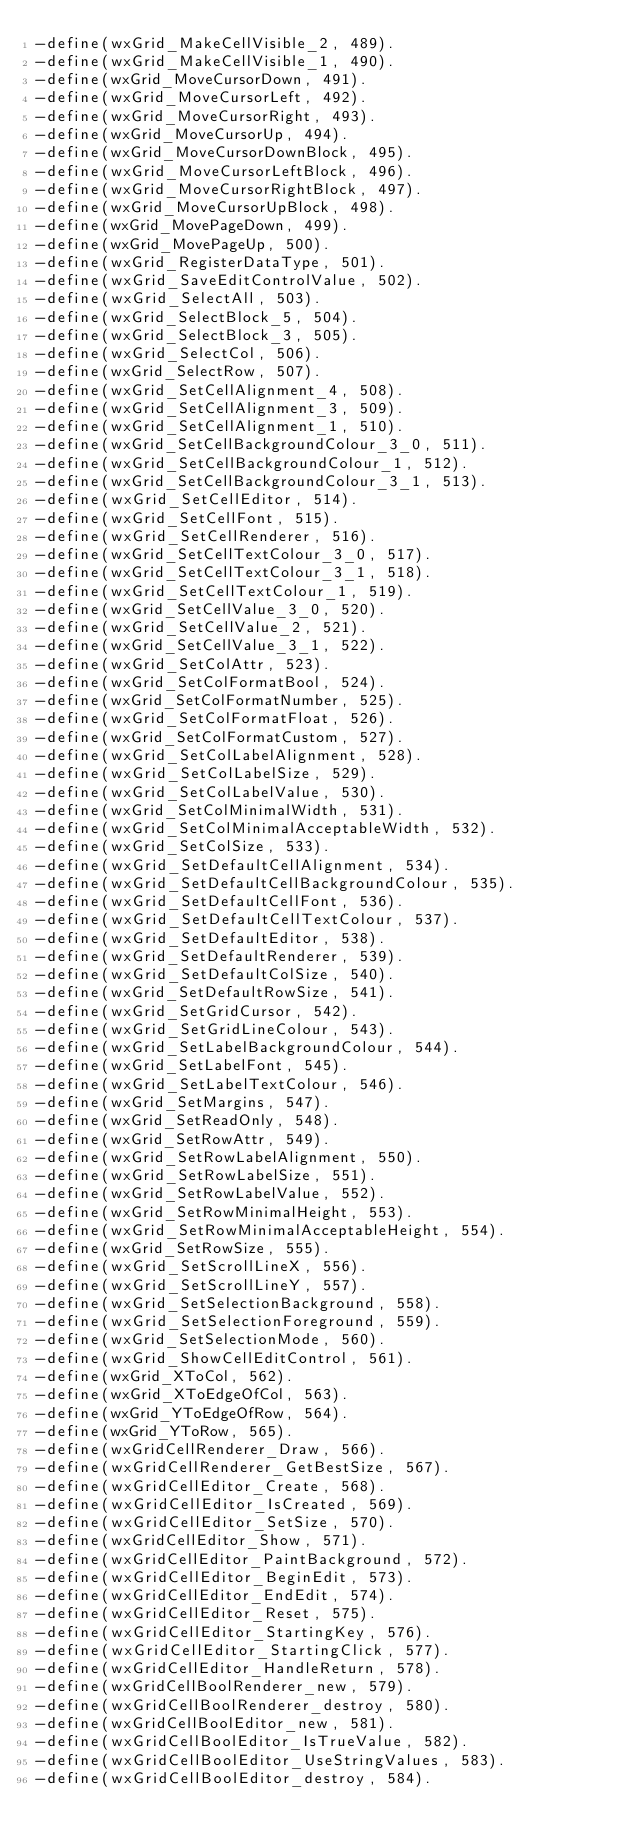<code> <loc_0><loc_0><loc_500><loc_500><_Erlang_>-define(wxGrid_MakeCellVisible_2, 489).
-define(wxGrid_MakeCellVisible_1, 490).
-define(wxGrid_MoveCursorDown, 491).
-define(wxGrid_MoveCursorLeft, 492).
-define(wxGrid_MoveCursorRight, 493).
-define(wxGrid_MoveCursorUp, 494).
-define(wxGrid_MoveCursorDownBlock, 495).
-define(wxGrid_MoveCursorLeftBlock, 496).
-define(wxGrid_MoveCursorRightBlock, 497).
-define(wxGrid_MoveCursorUpBlock, 498).
-define(wxGrid_MovePageDown, 499).
-define(wxGrid_MovePageUp, 500).
-define(wxGrid_RegisterDataType, 501).
-define(wxGrid_SaveEditControlValue, 502).
-define(wxGrid_SelectAll, 503).
-define(wxGrid_SelectBlock_5, 504).
-define(wxGrid_SelectBlock_3, 505).
-define(wxGrid_SelectCol, 506).
-define(wxGrid_SelectRow, 507).
-define(wxGrid_SetCellAlignment_4, 508).
-define(wxGrid_SetCellAlignment_3, 509).
-define(wxGrid_SetCellAlignment_1, 510).
-define(wxGrid_SetCellBackgroundColour_3_0, 511).
-define(wxGrid_SetCellBackgroundColour_1, 512).
-define(wxGrid_SetCellBackgroundColour_3_1, 513).
-define(wxGrid_SetCellEditor, 514).
-define(wxGrid_SetCellFont, 515).
-define(wxGrid_SetCellRenderer, 516).
-define(wxGrid_SetCellTextColour_3_0, 517).
-define(wxGrid_SetCellTextColour_3_1, 518).
-define(wxGrid_SetCellTextColour_1, 519).
-define(wxGrid_SetCellValue_3_0, 520).
-define(wxGrid_SetCellValue_2, 521).
-define(wxGrid_SetCellValue_3_1, 522).
-define(wxGrid_SetColAttr, 523).
-define(wxGrid_SetColFormatBool, 524).
-define(wxGrid_SetColFormatNumber, 525).
-define(wxGrid_SetColFormatFloat, 526).
-define(wxGrid_SetColFormatCustom, 527).
-define(wxGrid_SetColLabelAlignment, 528).
-define(wxGrid_SetColLabelSize, 529).
-define(wxGrid_SetColLabelValue, 530).
-define(wxGrid_SetColMinimalWidth, 531).
-define(wxGrid_SetColMinimalAcceptableWidth, 532).
-define(wxGrid_SetColSize, 533).
-define(wxGrid_SetDefaultCellAlignment, 534).
-define(wxGrid_SetDefaultCellBackgroundColour, 535).
-define(wxGrid_SetDefaultCellFont, 536).
-define(wxGrid_SetDefaultCellTextColour, 537).
-define(wxGrid_SetDefaultEditor, 538).
-define(wxGrid_SetDefaultRenderer, 539).
-define(wxGrid_SetDefaultColSize, 540).
-define(wxGrid_SetDefaultRowSize, 541).
-define(wxGrid_SetGridCursor, 542).
-define(wxGrid_SetGridLineColour, 543).
-define(wxGrid_SetLabelBackgroundColour, 544).
-define(wxGrid_SetLabelFont, 545).
-define(wxGrid_SetLabelTextColour, 546).
-define(wxGrid_SetMargins, 547).
-define(wxGrid_SetReadOnly, 548).
-define(wxGrid_SetRowAttr, 549).
-define(wxGrid_SetRowLabelAlignment, 550).
-define(wxGrid_SetRowLabelSize, 551).
-define(wxGrid_SetRowLabelValue, 552).
-define(wxGrid_SetRowMinimalHeight, 553).
-define(wxGrid_SetRowMinimalAcceptableHeight, 554).
-define(wxGrid_SetRowSize, 555).
-define(wxGrid_SetScrollLineX, 556).
-define(wxGrid_SetScrollLineY, 557).
-define(wxGrid_SetSelectionBackground, 558).
-define(wxGrid_SetSelectionForeground, 559).
-define(wxGrid_SetSelectionMode, 560).
-define(wxGrid_ShowCellEditControl, 561).
-define(wxGrid_XToCol, 562).
-define(wxGrid_XToEdgeOfCol, 563).
-define(wxGrid_YToEdgeOfRow, 564).
-define(wxGrid_YToRow, 565).
-define(wxGridCellRenderer_Draw, 566).
-define(wxGridCellRenderer_GetBestSize, 567).
-define(wxGridCellEditor_Create, 568).
-define(wxGridCellEditor_IsCreated, 569).
-define(wxGridCellEditor_SetSize, 570).
-define(wxGridCellEditor_Show, 571).
-define(wxGridCellEditor_PaintBackground, 572).
-define(wxGridCellEditor_BeginEdit, 573).
-define(wxGridCellEditor_EndEdit, 574).
-define(wxGridCellEditor_Reset, 575).
-define(wxGridCellEditor_StartingKey, 576).
-define(wxGridCellEditor_StartingClick, 577).
-define(wxGridCellEditor_HandleReturn, 578).
-define(wxGridCellBoolRenderer_new, 579).
-define(wxGridCellBoolRenderer_destroy, 580).
-define(wxGridCellBoolEditor_new, 581).
-define(wxGridCellBoolEditor_IsTrueValue, 582).
-define(wxGridCellBoolEditor_UseStringValues, 583).
-define(wxGridCellBoolEditor_destroy, 584).</code> 